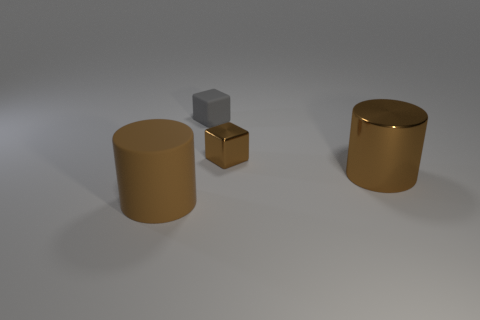Add 2 small brown metal balls. How many objects exist? 6 Subtract 0 purple blocks. How many objects are left? 4 Subtract all gray matte blocks. Subtract all large brown objects. How many objects are left? 1 Add 2 gray things. How many gray things are left? 3 Add 2 big brown metallic things. How many big brown metallic things exist? 3 